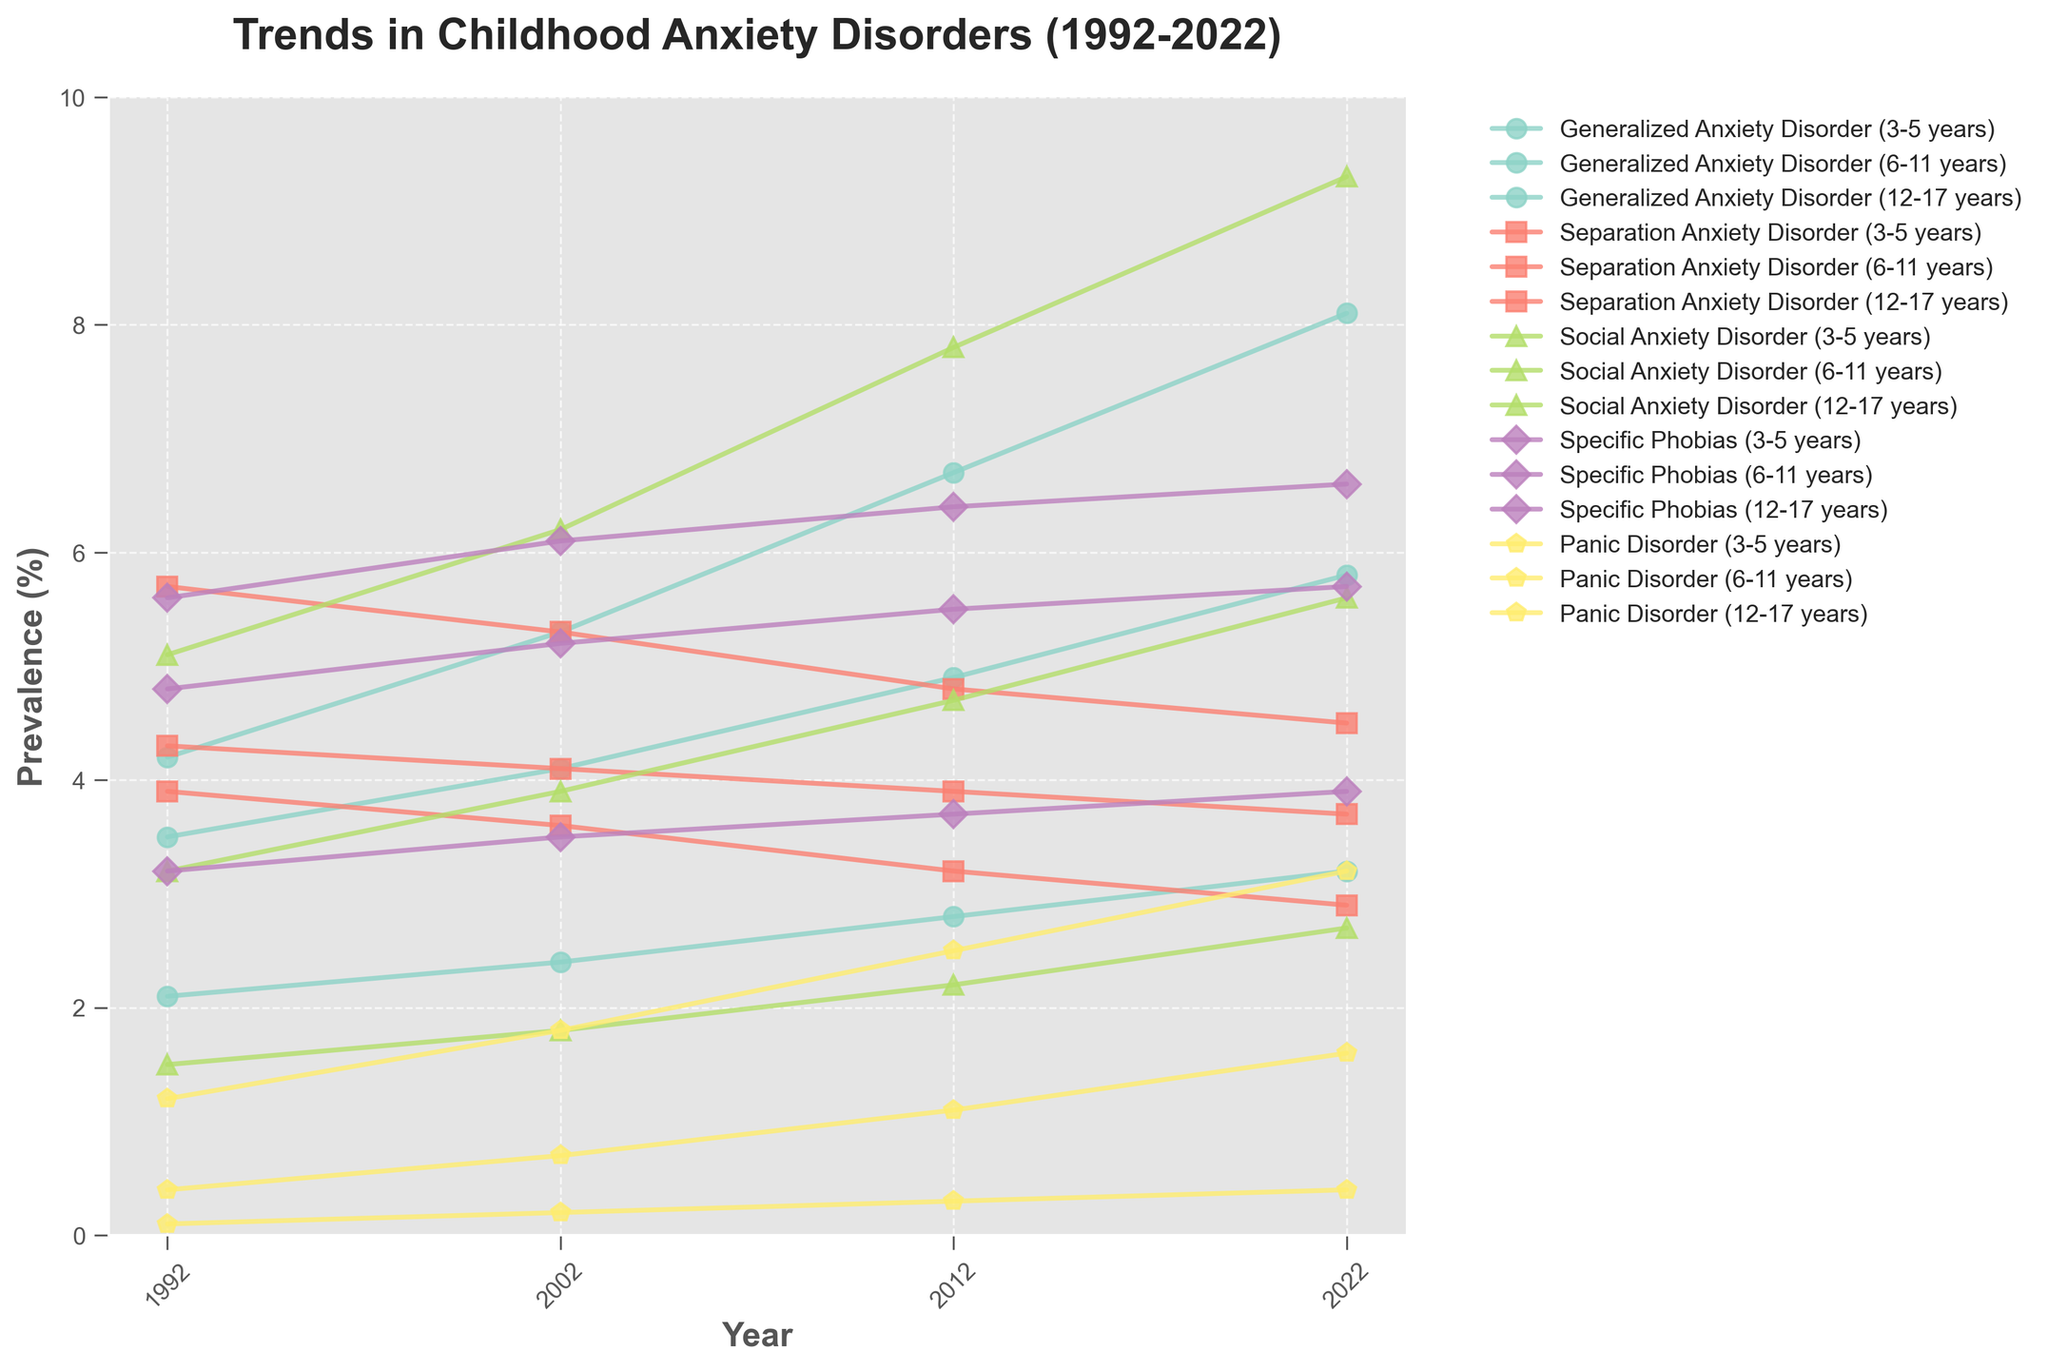What was the trend in the prevalence of Generalized Anxiety Disorder (GAD) among 12-17 year-olds from 1992 to 2022? The plot for Generalized Anxiety Disorder (GAD) among 12-17 year-olds shows an upward trend from 1992 (4.2%) to 2022 (8.1%). First, trace the line corresponding to GAD and 12-17 year-olds from 1992 to 2022. Observe the yearly increments to establish the trend.
Answer: Upward Which age group had the highest prevalence of Social Anxiety Disorder in 2022? Look for the markers representing Social Anxiety Disorder in 2022 and compare the height of the markers among the three age groups. The highest marker corresponds to the 12-17 years age group with a prevalence of 9.3%.
Answer: 12-17 years By how much did the prevalence of Panic Disorder among 6-11 year-olds change from 2012 to 2022? Note the values for 2012 and 2022 for Panic Disorder in the 6-11 years age group (2012: 1.1%, 2022: 1.6%). Subtract the 2012 value from the 2022 value to find the change: 1.6% - 1.1% = 0.5%.
Answer: 0.5% Which disorder saw a decrease in prevalence among 3-5 year-olds between 1992 and 2022? Compare the prevalence values for each disorder in 1992 and 2022 for the 3-5 years age group. Only Separation Anxiety Disorder shows a decrease from 4.3% in 1992 to 3.7% in 2022.
Answer: Separation Anxiety Disorder What is the average prevalence of Social Anxiety Disorder among all age groups in 2012? Obtain the values for Social Anxiety Disorder in 2012 for each age group (3-5 years: 2.2%, 6-11 years: 4.7%, 12-17 years: 7.8%). Calculate the average: (2.2 + 4.7 + 7.8) / 3 = 4.9%.
Answer: 4.9% In which year did Specific Phobias have the highest prevalence among 12-17 year-olds? Trace the line for Specific Phobias in the 12-17 years age group and compare the peaks over the years. The highest prevalence is in 2012 with a value of 6.4%.
Answer: 2012 Between 2002 and 2012, which disorder saw the most significant increase in prevalence among 12-17 year-olds? Analyze the increments in prevalence for each disorder between 2002 and 2012 for 12-17 years age group. Social Anxiety Disorder increased from 6.2% in 2002 to 7.8% in 2012, the highest increase of 1.6%.
Answer: Social Anxiety Disorder Which age group consistently had the lowest prevalence of Panic Disorder from 1992 to 2022? For each year, compare the height of the markers representing Panic Disorder among the three age groups. The 3-5 years age group consistently has the lowest prevalence, starting from 0.1% in 1992 and ending at 0.4% in 2022.
Answer: 3-5 years 